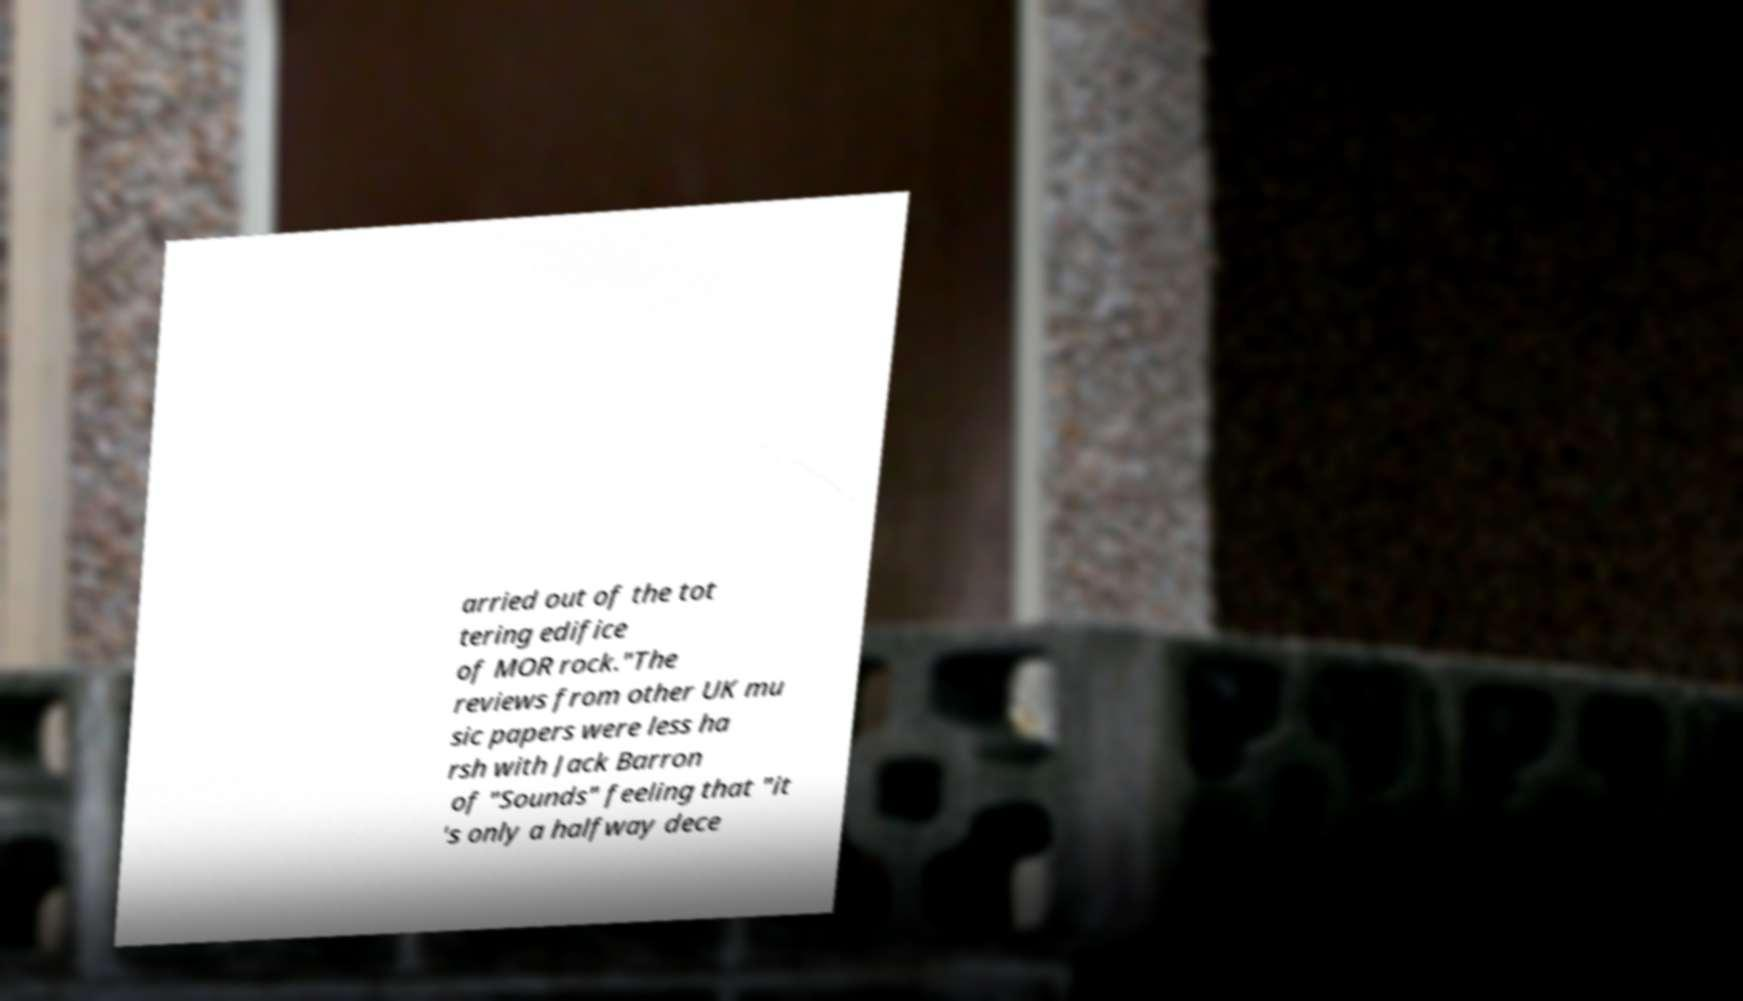I need the written content from this picture converted into text. Can you do that? arried out of the tot tering edifice of MOR rock."The reviews from other UK mu sic papers were less ha rsh with Jack Barron of "Sounds" feeling that "it 's only a halfway dece 